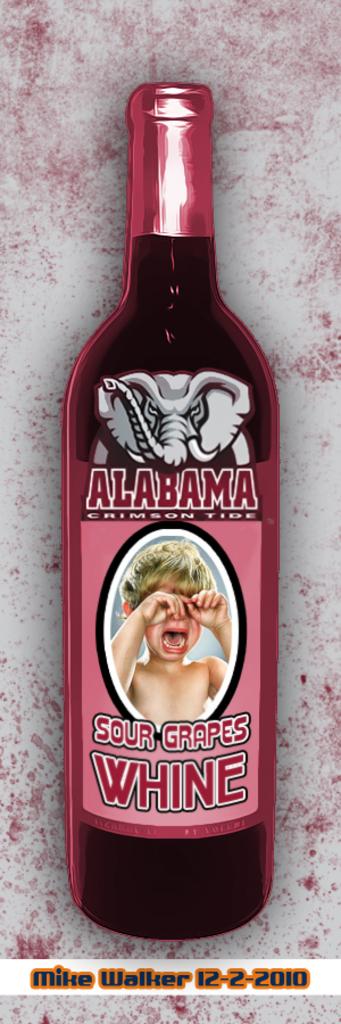What kind of drink is this?
Ensure brevity in your answer.  Sour grapes whine. 